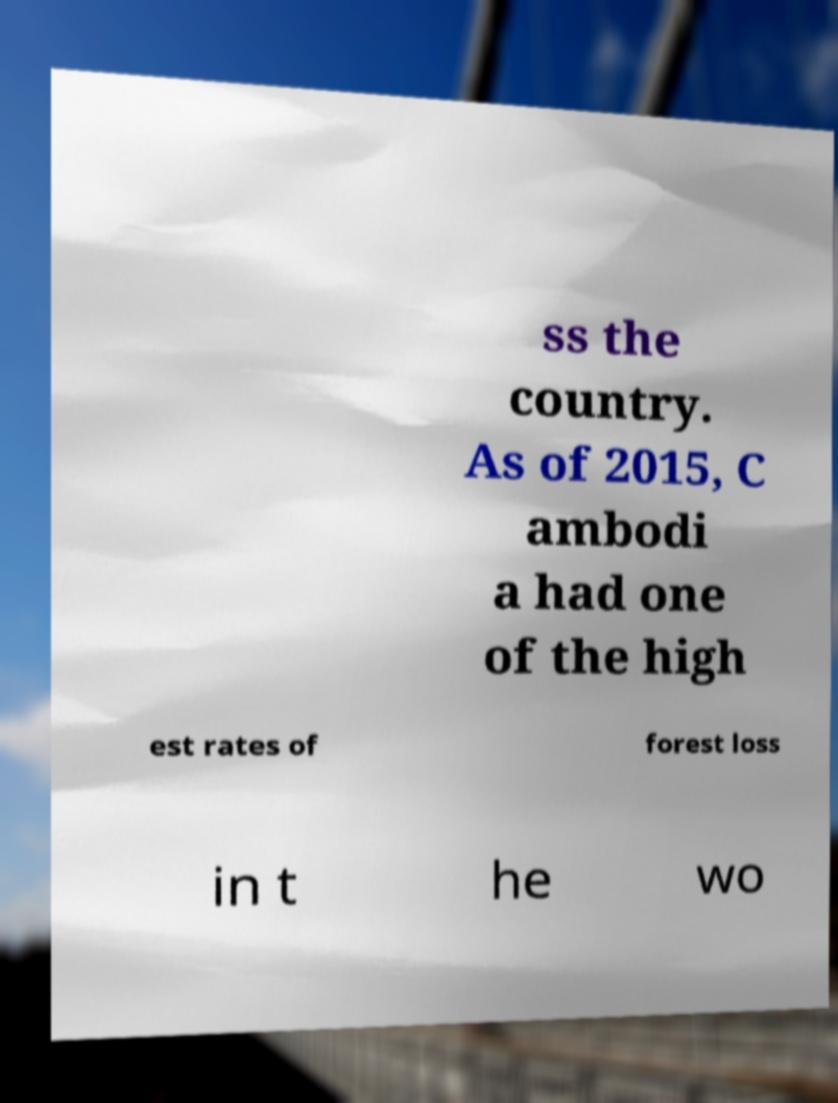For documentation purposes, I need the text within this image transcribed. Could you provide that? ss the country. As of 2015, C ambodi a had one of the high est rates of forest loss in t he wo 